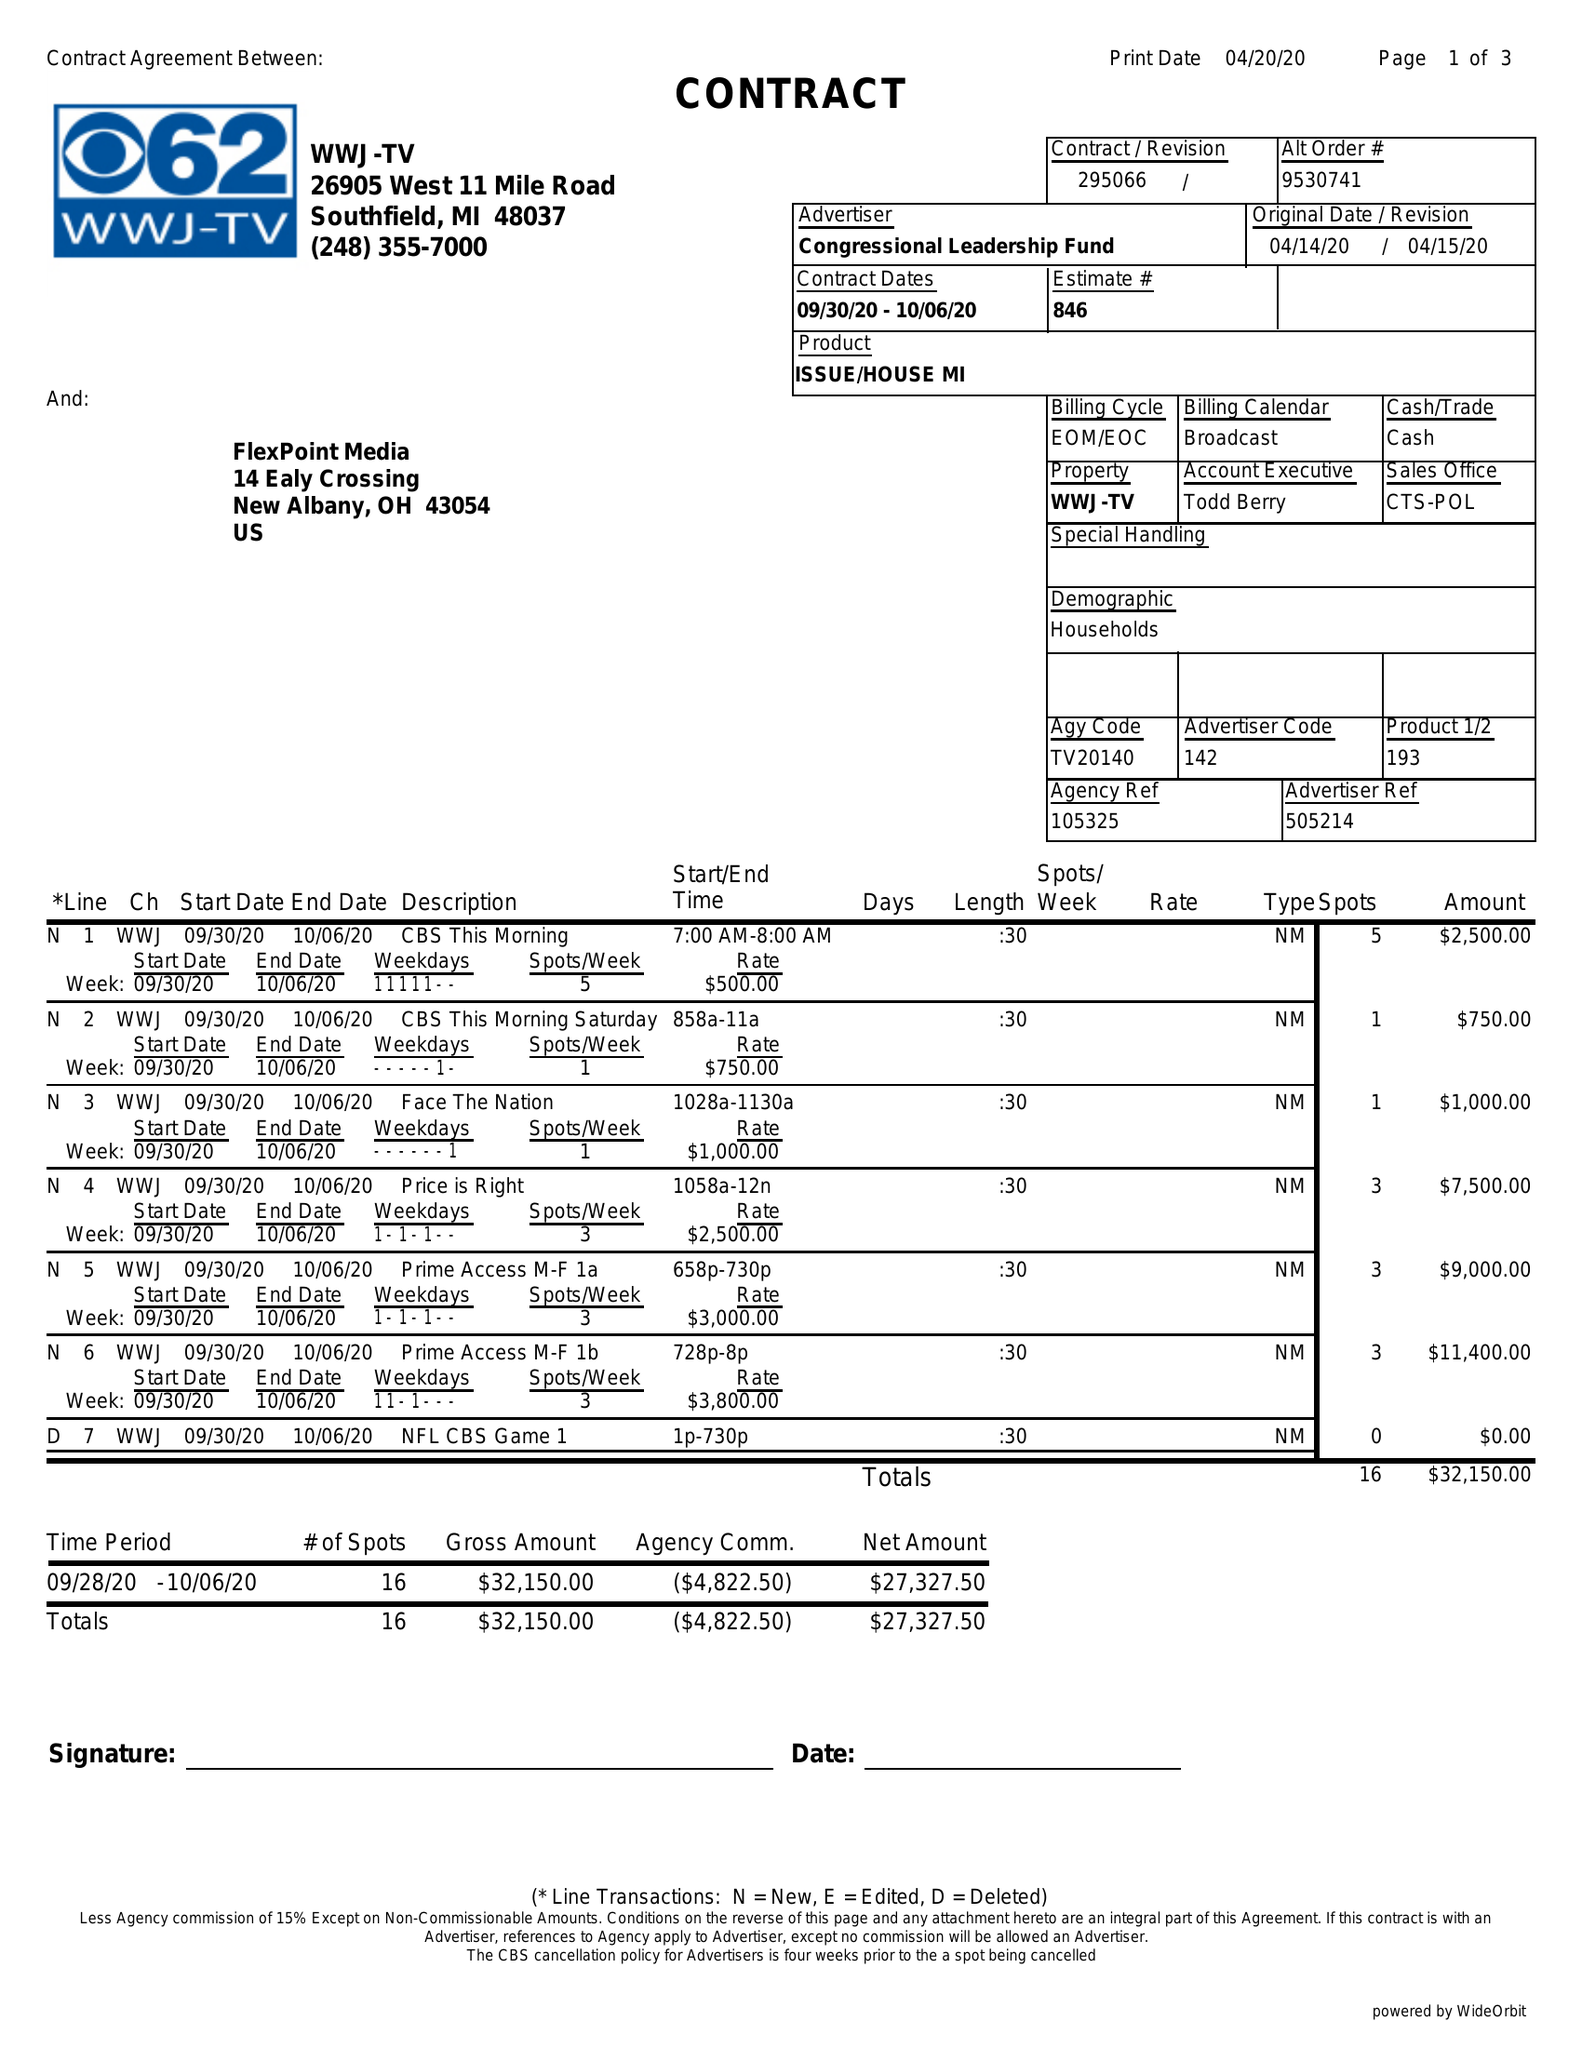What is the value for the gross_amount?
Answer the question using a single word or phrase. 32150.00 